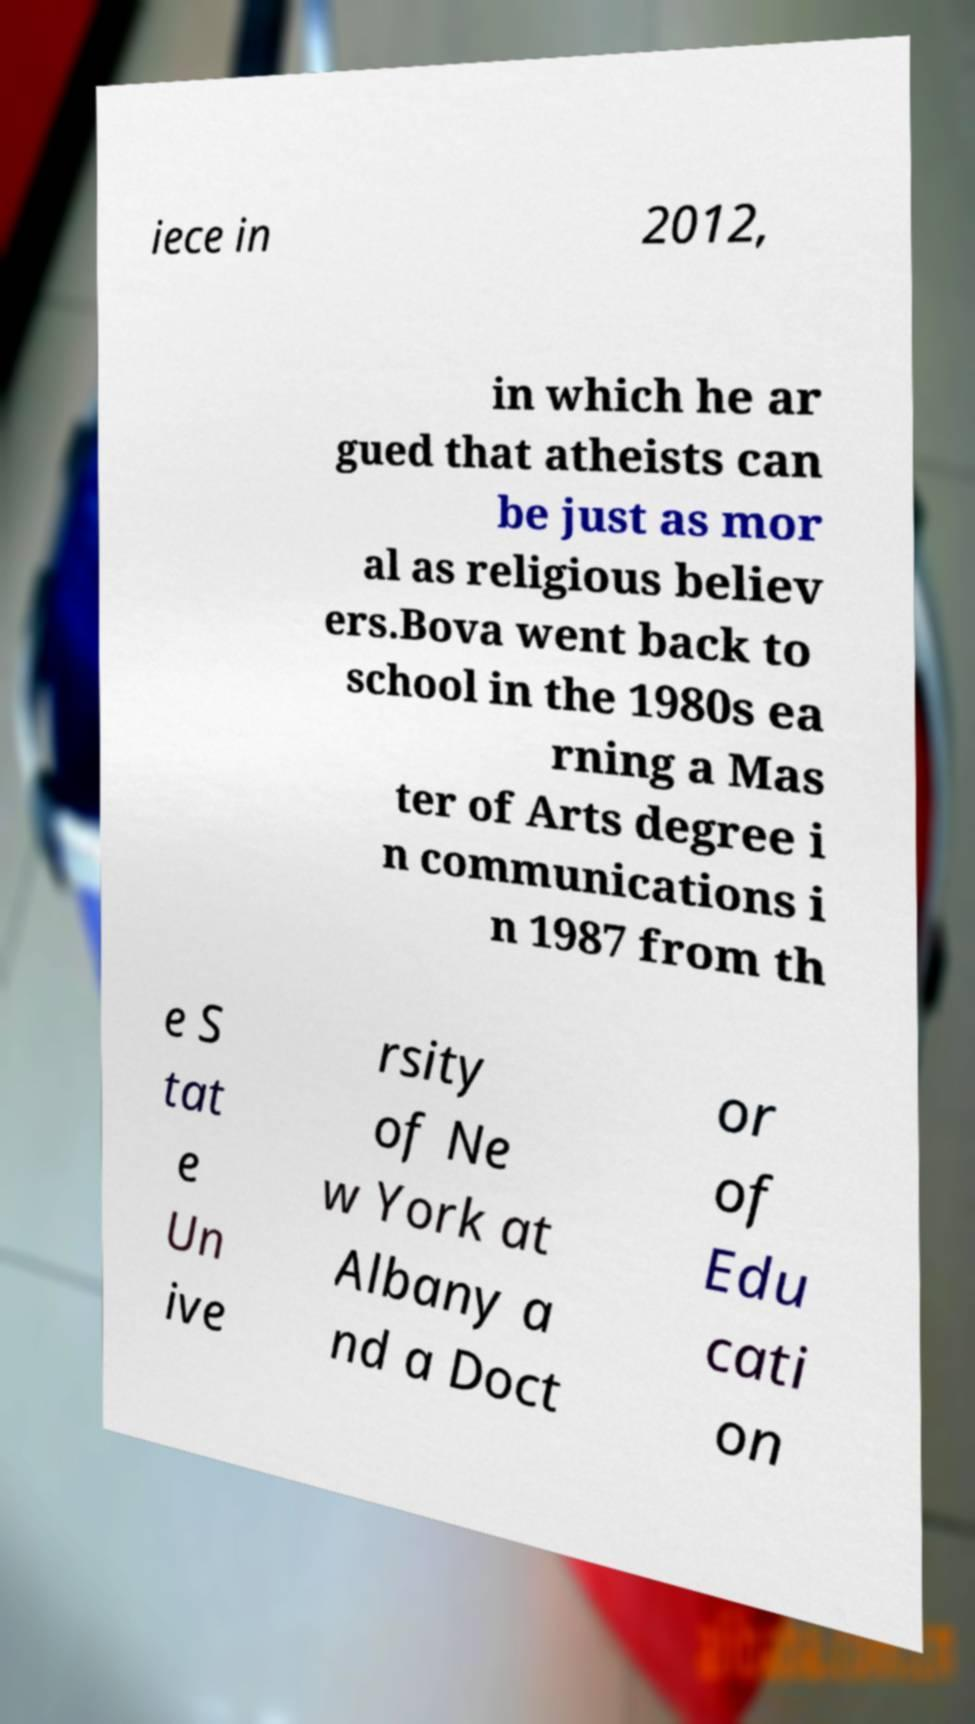Could you extract and type out the text from this image? iece in 2012, in which he ar gued that atheists can be just as mor al as religious believ ers.Bova went back to school in the 1980s ea rning a Mas ter of Arts degree i n communications i n 1987 from th e S tat e Un ive rsity of Ne w York at Albany a nd a Doct or of Edu cati on 